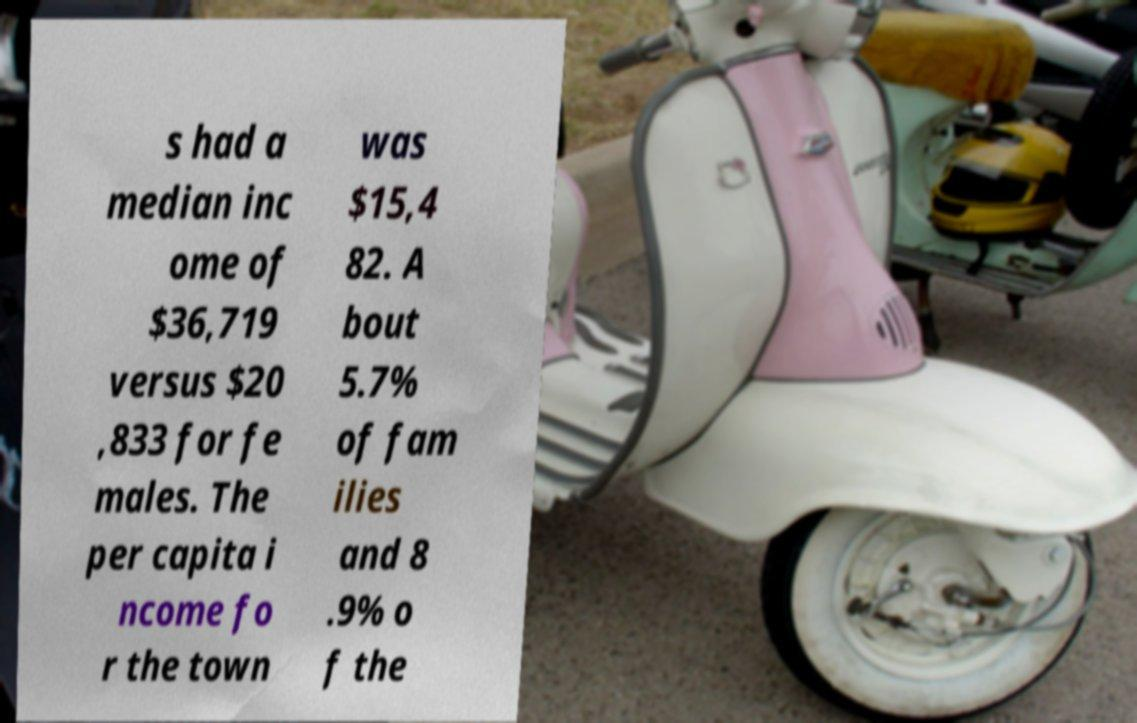Can you read and provide the text displayed in the image?This photo seems to have some interesting text. Can you extract and type it out for me? s had a median inc ome of $36,719 versus $20 ,833 for fe males. The per capita i ncome fo r the town was $15,4 82. A bout 5.7% of fam ilies and 8 .9% o f the 